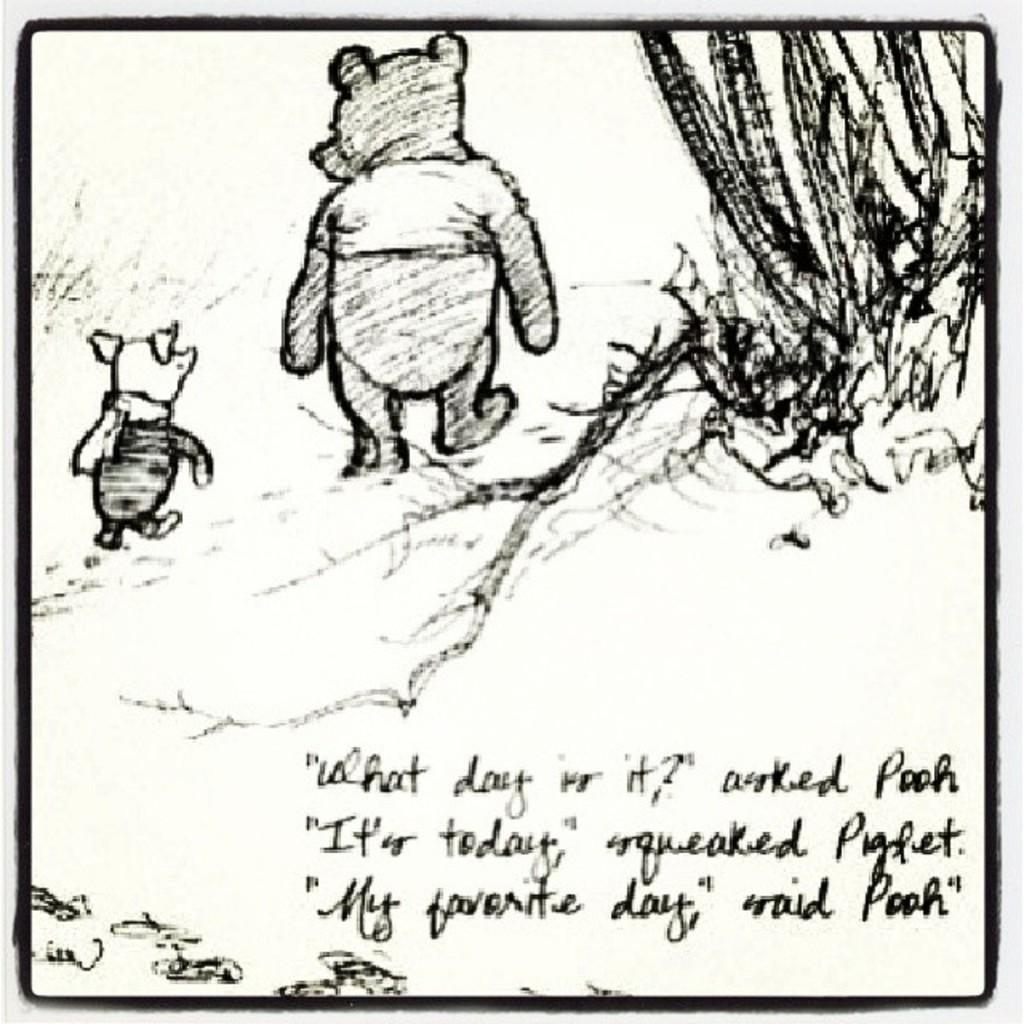What type of artwork is depicted in the image? The image is a drawing. What can be seen in the center of the drawing? There are two animals in the center of the image. What is located on the right side of the drawing? There is a plant on the right side of the image. What information is provided at the bottom of the drawing? There is some text written at the bottom of the image. What type of train can be seen in the background of the drawing? There is no train present in the drawing; it features two animals, a plant, and some text. What kind of apparatus is being used by the animals in the drawing? There is no apparatus visible in the drawing; the animals are not shown using any tools or devices. 